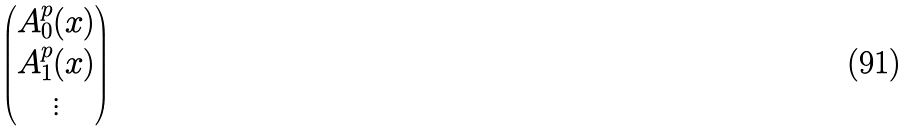Convert formula to latex. <formula><loc_0><loc_0><loc_500><loc_500>\begin{pmatrix} A _ { 0 } ^ { p } ( x ) \\ A _ { 1 } ^ { p } ( x ) \\ \vdots \end{pmatrix}</formula> 